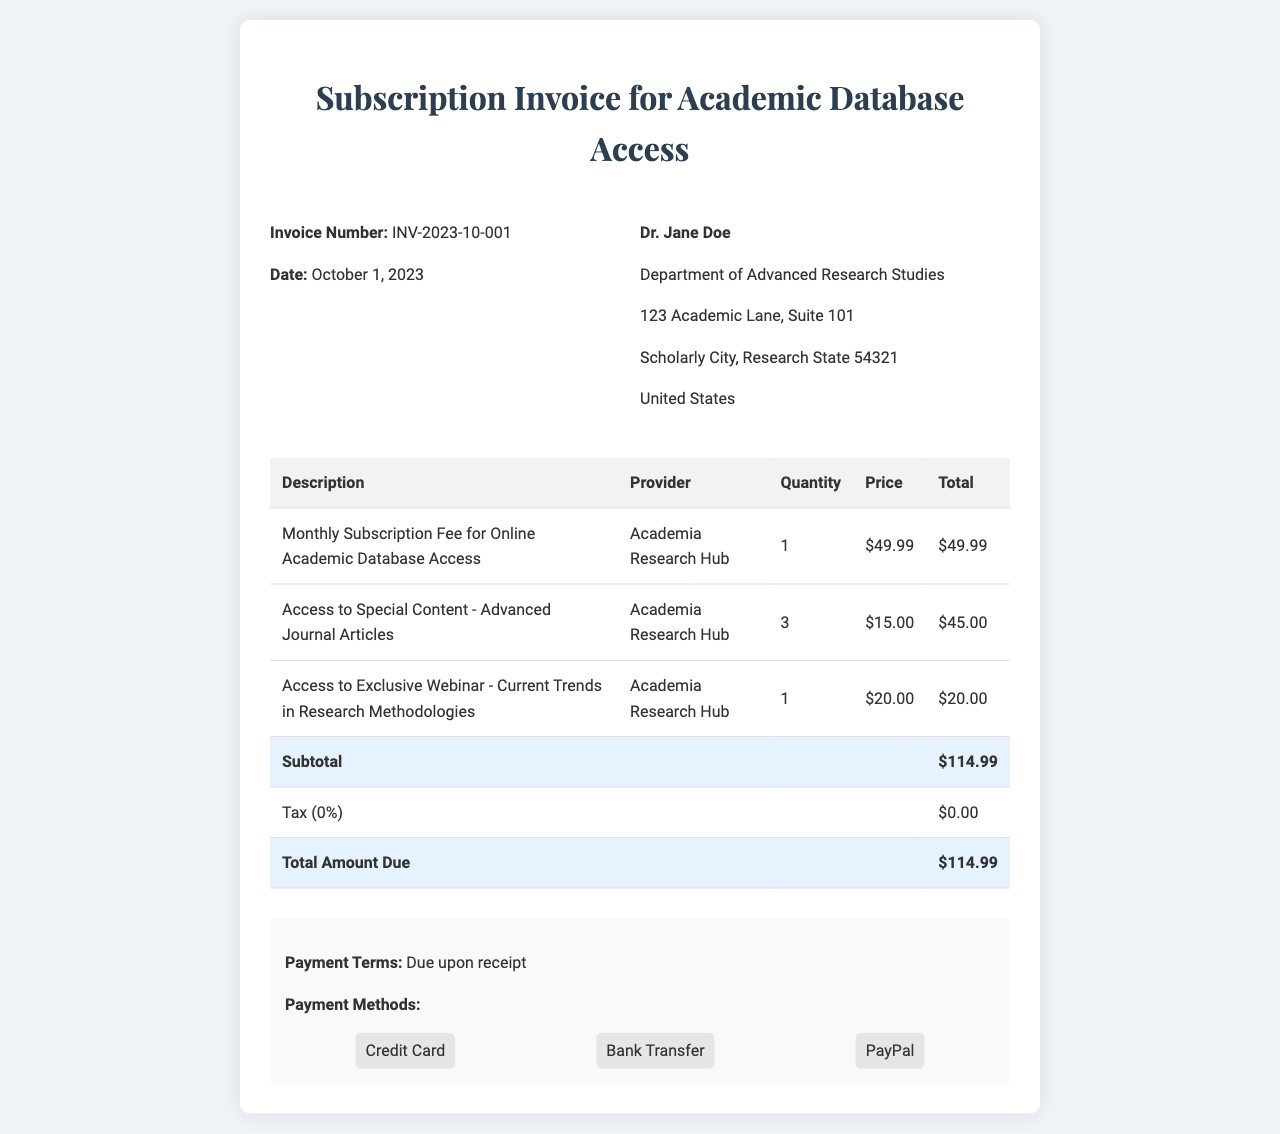What is the invoice number? The invoice number is specified in the document under the invoice details section as INV-2023-10-001.
Answer: INV-2023-10-001 What is the total amount due? The total amount due is mentioned in the subtotal section as the final amount that needs to be paid.
Answer: $114.99 Who is the subscriber listed in the invoice? The subscriber's name and details are provided at the top of the document, specifically under the billing address section.
Answer: Dr. Jane Doe How many special content accesses are included in the invoice? The document lists the number of special content accesses under the description of access to special content, which is specified in quantity.
Answer: 3 What is the price of the monthly subscription fee? The monthly subscription fee is indicated directly in the invoice details under the corresponding description line item.
Answer: $49.99 What percentage is the tax rate applied in this invoice? The tax section clearly states the applicable tax rate for this invoice.
Answer: 0% What is the payment term for the invoice? The payment terms are outlined in the payment information section of the document and describe when payment is expected.
Answer: Due upon receipt What is the quantity of the exclusive webinar access? The quantity of the exclusive webinar access is given in the corresponding line item description about the webinar.
Answer: 1 Which provider is listed for the services? The provider's name is mentioned repeatedly throughout the invoice in each line item description of services provided.
Answer: Academia Research Hub 